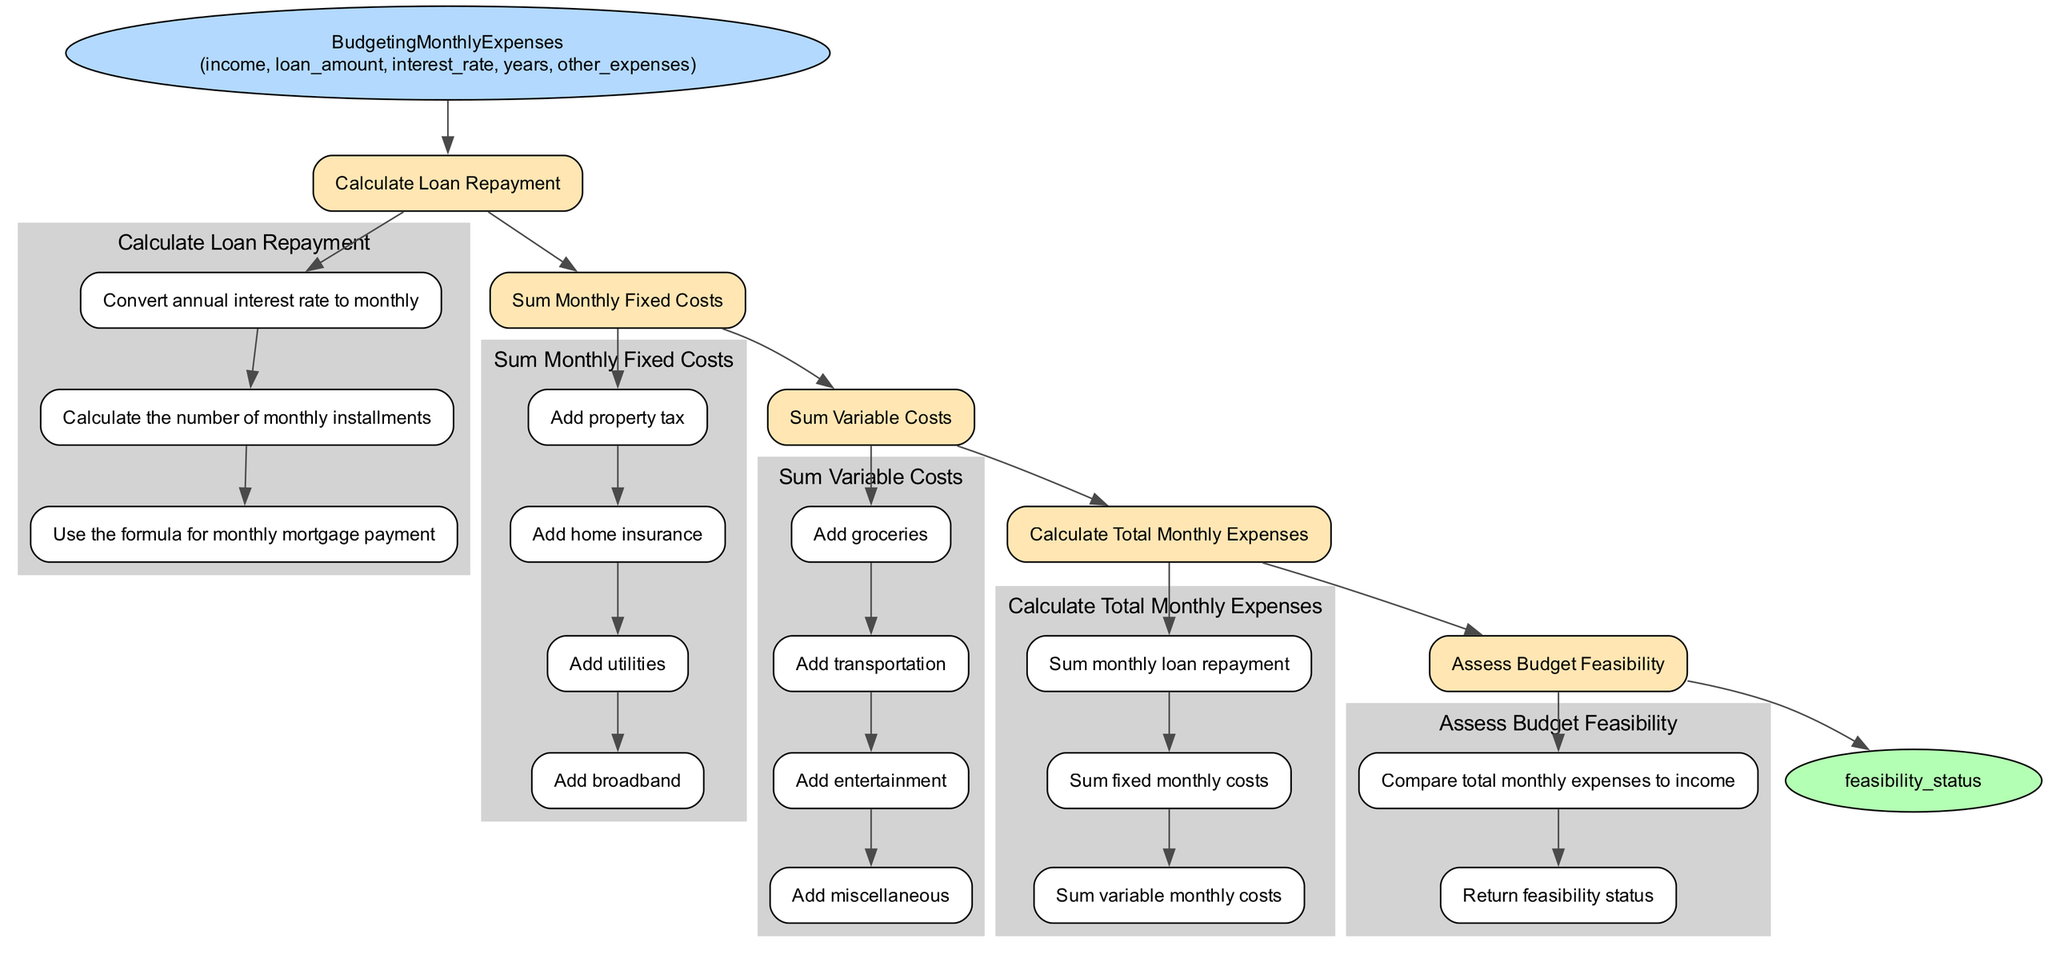What is the function name in the diagram? The function name is located at the starting node, which is labeled "BudgetingMonthlyExpenses."
Answer: BudgetingMonthlyExpenses How many parameters does the function take? Counting the items listed in the parameters section shows there are five parameters: income, loan amount, interest rate, years, and other expenses.
Answer: 5 What is the first action in the steps? The first action is identified in the first step of the flowchart, which states "Calculate Loan Repayment."
Answer: Calculate Loan Repayment Which substep is listed first under "Sum Variable Costs"? The first substep under "Sum Variable Costs" is "Add groceries." This can be found in the subgroup of the third action in the flowchart.
Answer: Add groceries What is the final action before the output? The final action before reaching the output node is "Assess Budget Feasibility," which can be seen as the last step in the diagram.
Answer: Assess Budget Feasibility What does the last node represent? The last node represents the output of the function, which is labeled "feasibility_status," indicating the result of the function after processing all previous steps.
Answer: feasibility_status How do you calculate total monthly expenses? Total monthly expenses are calculated by summing the results from three components: monthly loan repayment, fixed monthly costs, and variable monthly costs, as outlined in "Calculate Total Monthly Expenses."
Answer: Sum monthly loan repayment, sum fixed monthly costs, sum variable monthly costs If total monthly expenses exceed income, what would the feasibility status be? The feasibility status would be unfavorable, suggesting that the expenses are unsustainable given the income. This reasoning follows the comparison made in "Assess Budget Feasibility" where total monthly expenses are checked against income.
Answer: Unfavorable What specific costs are considered as fixed costs? Fixed costs include property tax, home insurance, utilities, and broadband, which are detailed in the "Sum Monthly Fixed Costs" action.
Answer: Property tax, home insurance, utilities, broadband 